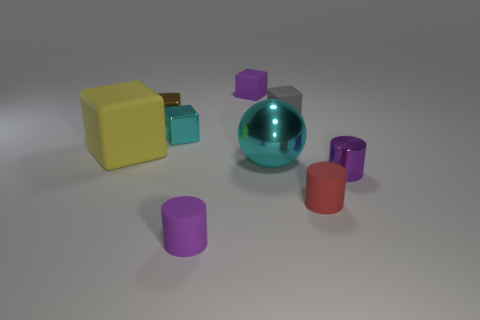Subtract 1 cubes. How many cubes are left? 4 Subtract all brown cubes. How many cubes are left? 4 Subtract all large yellow cubes. How many cubes are left? 4 Subtract all green cubes. Subtract all cyan cylinders. How many cubes are left? 5 Add 1 red things. How many objects exist? 10 Subtract all spheres. How many objects are left? 8 Add 7 tiny gray objects. How many tiny gray objects exist? 8 Subtract 1 cyan cubes. How many objects are left? 8 Subtract all large cyan spheres. Subtract all shiny objects. How many objects are left? 4 Add 7 purple shiny cylinders. How many purple shiny cylinders are left? 8 